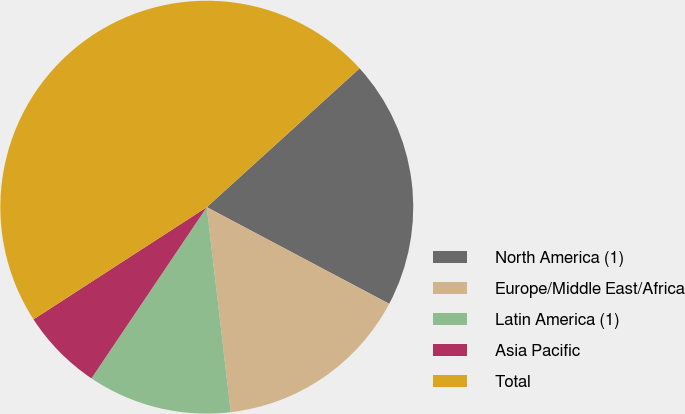Convert chart. <chart><loc_0><loc_0><loc_500><loc_500><pie_chart><fcel>North America (1)<fcel>Europe/Middle East/Africa<fcel>Latin America (1)<fcel>Asia Pacific<fcel>Total<nl><fcel>19.49%<fcel>15.39%<fcel>11.29%<fcel>6.42%<fcel>47.41%<nl></chart> 